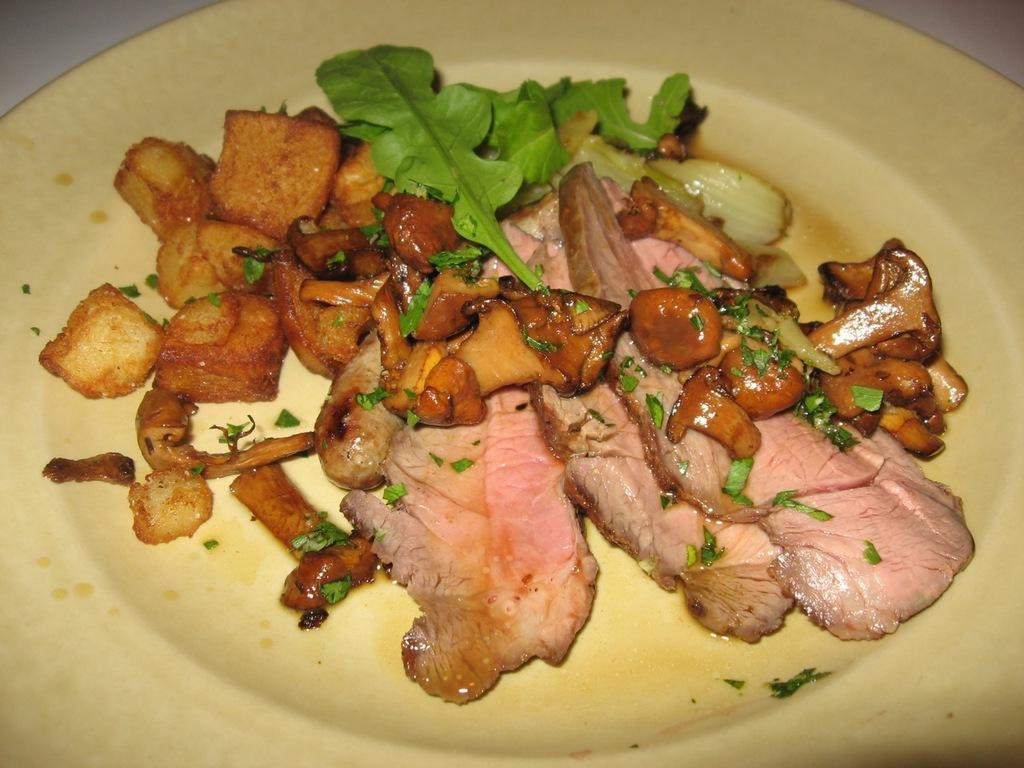What can be seen on the plate in the image? There is a food item on the plate in the image. Can you describe the plate in the image? The plate is visible in the image, but no specific details about its shape, color, or material are provided. How many giants are visible in the image? There are no giants present in the image. Is there a sink visible in the image? There is no mention of a sink in the provided facts, so it cannot be determined if one is present in the image. 